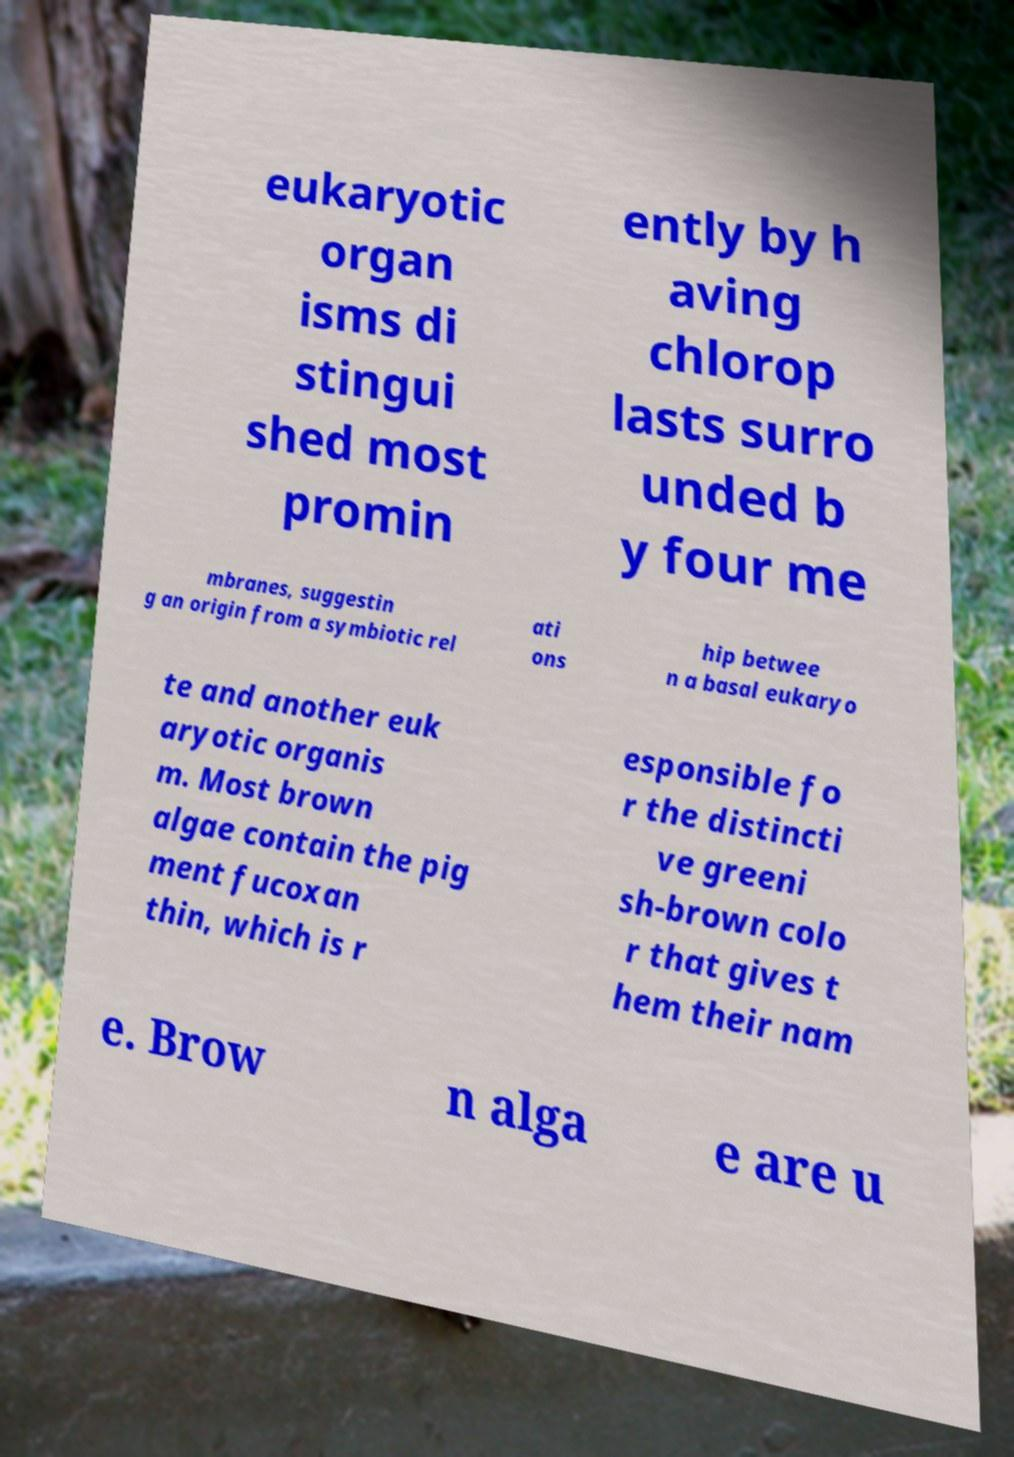What messages or text are displayed in this image? I need them in a readable, typed format. eukaryotic organ isms di stingui shed most promin ently by h aving chlorop lasts surro unded b y four me mbranes, suggestin g an origin from a symbiotic rel ati ons hip betwee n a basal eukaryo te and another euk aryotic organis m. Most brown algae contain the pig ment fucoxan thin, which is r esponsible fo r the distincti ve greeni sh-brown colo r that gives t hem their nam e. Brow n alga e are u 